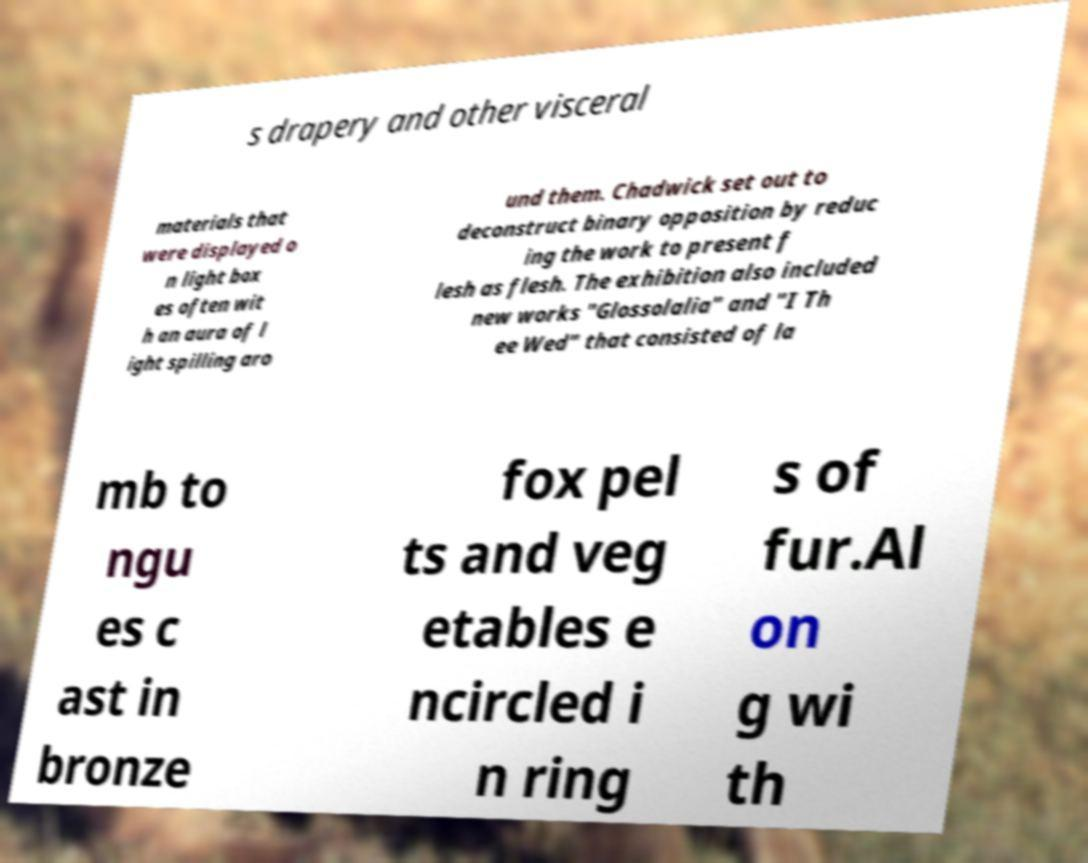For documentation purposes, I need the text within this image transcribed. Could you provide that? s drapery and other visceral materials that were displayed o n light box es often wit h an aura of l ight spilling aro und them. Chadwick set out to deconstruct binary opposition by reduc ing the work to present f lesh as flesh. The exhibition also included new works "Glossolalia" and "I Th ee Wed" that consisted of la mb to ngu es c ast in bronze fox pel ts and veg etables e ncircled i n ring s of fur.Al on g wi th 